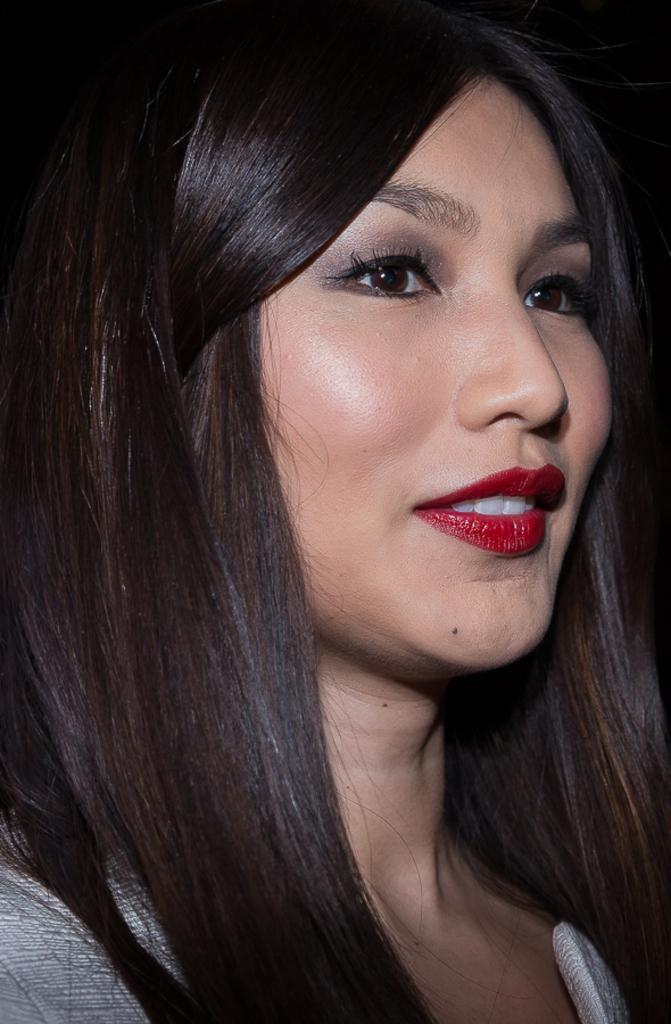What is the main subject of the image? The main subject of the image is a woman. Can you describe the woman's position in the image? The woman is in the center of the image. What is the woman's facial expression in the image? The woman is smiling. Can you tell me how many frogs are sitting next to the woman in the image? There are no frogs present in the image, so it is not possible to determine how many might be sitting next to the woman. 